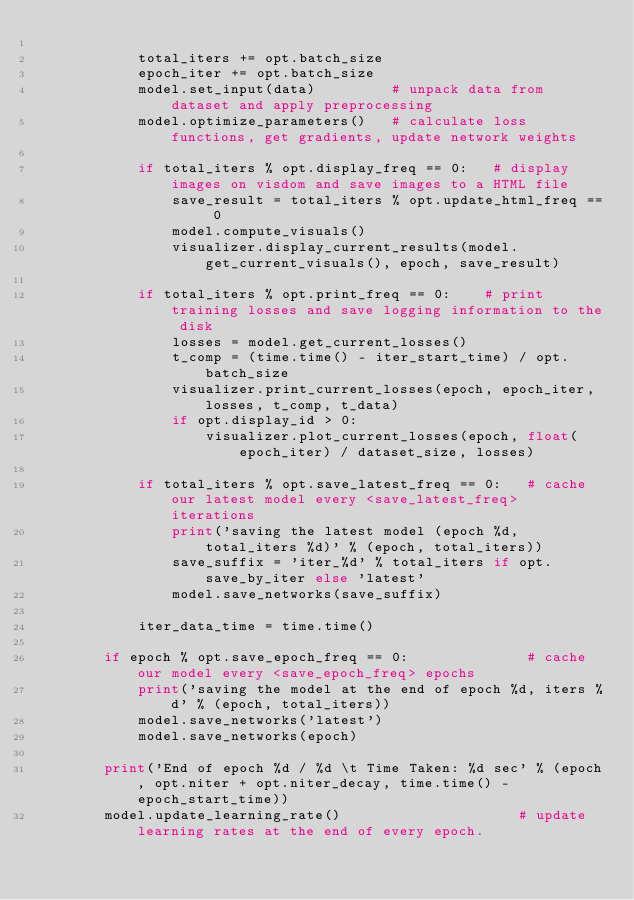<code> <loc_0><loc_0><loc_500><loc_500><_Python_>
            total_iters += opt.batch_size
            epoch_iter += opt.batch_size
            model.set_input(data)         # unpack data from dataset and apply preprocessing
            model.optimize_parameters()   # calculate loss functions, get gradients, update network weights

            if total_iters % opt.display_freq == 0:   # display images on visdom and save images to a HTML file
                save_result = total_iters % opt.update_html_freq == 0
                model.compute_visuals()
                visualizer.display_current_results(model.get_current_visuals(), epoch, save_result)

            if total_iters % opt.print_freq == 0:    # print training losses and save logging information to the disk
                losses = model.get_current_losses()
                t_comp = (time.time() - iter_start_time) / opt.batch_size
                visualizer.print_current_losses(epoch, epoch_iter, losses, t_comp, t_data)
                if opt.display_id > 0:
                    visualizer.plot_current_losses(epoch, float(epoch_iter) / dataset_size, losses)

            if total_iters % opt.save_latest_freq == 0:   # cache our latest model every <save_latest_freq> iterations
                print('saving the latest model (epoch %d, total_iters %d)' % (epoch, total_iters))
                save_suffix = 'iter_%d' % total_iters if opt.save_by_iter else 'latest'
                model.save_networks(save_suffix)

            iter_data_time = time.time()

        if epoch % opt.save_epoch_freq == 0:              # cache our model every <save_epoch_freq> epochs
            print('saving the model at the end of epoch %d, iters %d' % (epoch, total_iters))
            model.save_networks('latest')
            model.save_networks(epoch)

        print('End of epoch %d / %d \t Time Taken: %d sec' % (epoch, opt.niter + opt.niter_decay, time.time() - epoch_start_time))
        model.update_learning_rate()                     # update learning rates at the end of every epoch.
</code> 